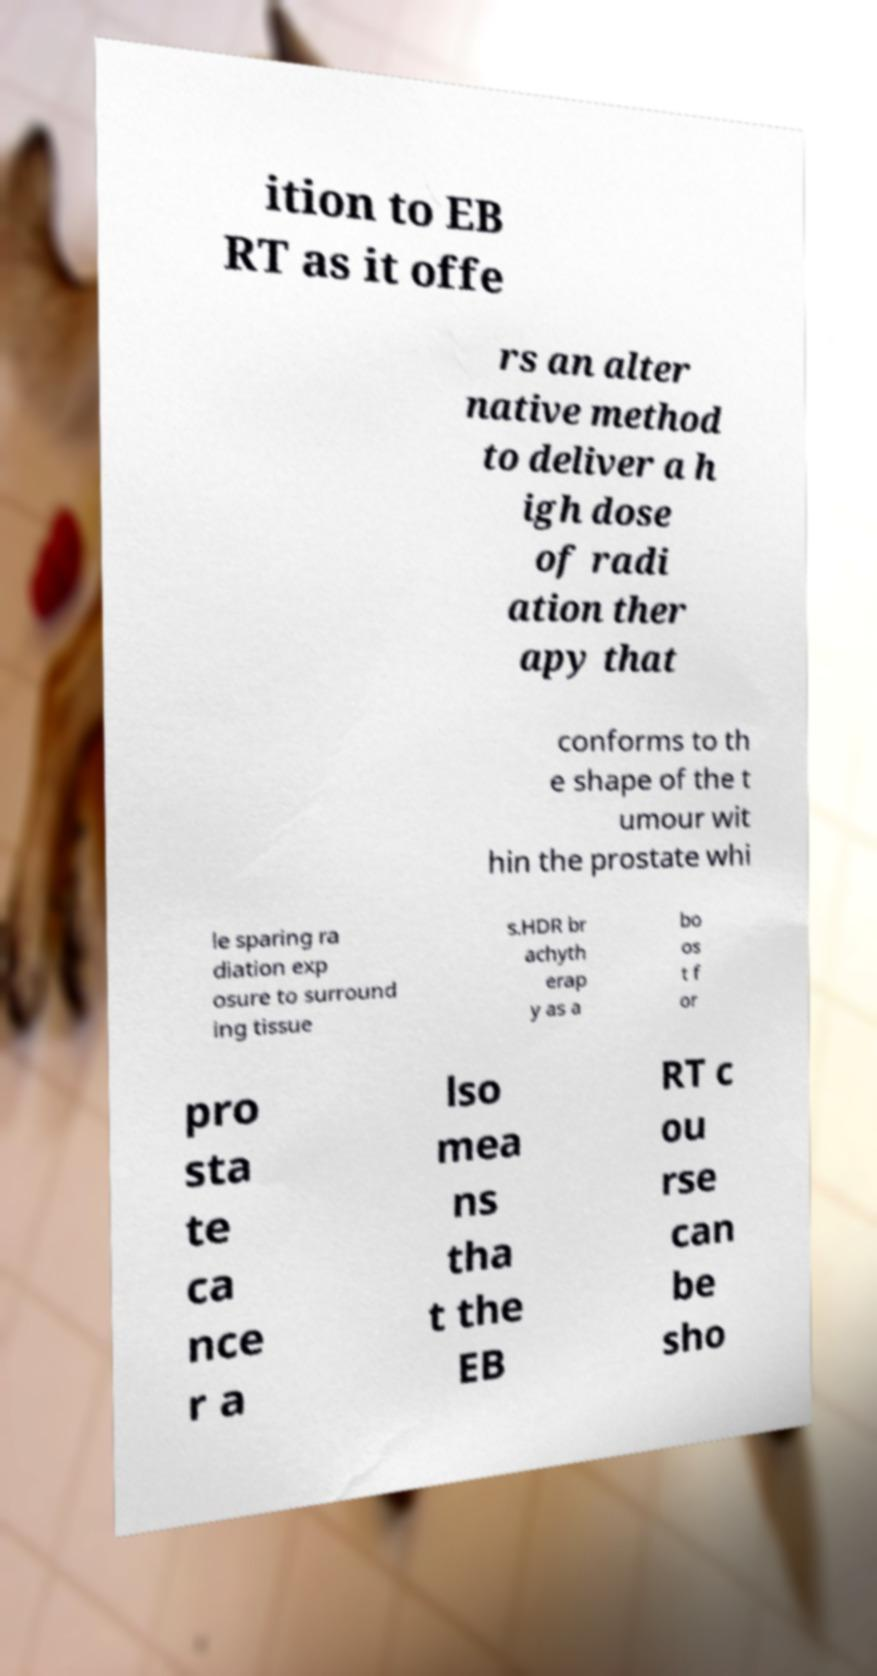Please read and relay the text visible in this image. What does it say? ition to EB RT as it offe rs an alter native method to deliver a h igh dose of radi ation ther apy that conforms to th e shape of the t umour wit hin the prostate whi le sparing ra diation exp osure to surround ing tissue s.HDR br achyth erap y as a bo os t f or pro sta te ca nce r a lso mea ns tha t the EB RT c ou rse can be sho 